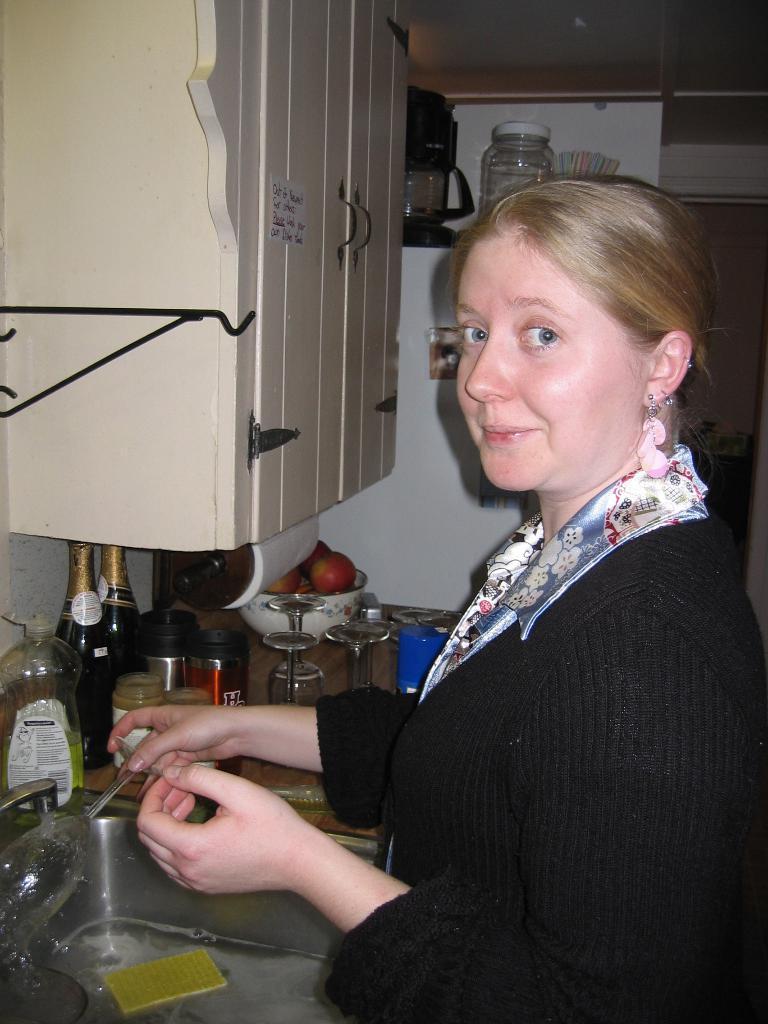How would you summarize this image in a sentence or two? The image is taken in the kitchen. On the right side of the image we can see a lady standing, before her there is a counter top and we can see a sink, bottles, glasses, bowls and some things placed on the table. On the left there are cupboards. At the top there is a shelf and we can see jars placed in the shelf. 